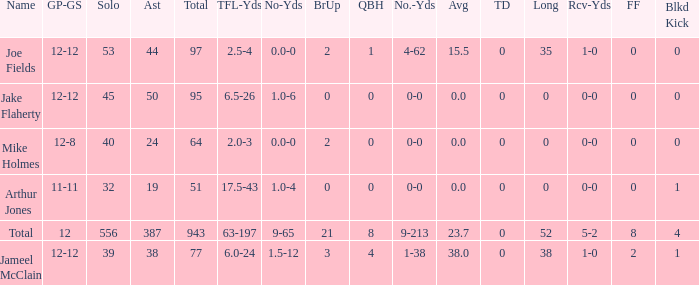How many players named jake flaherty? 1.0. 